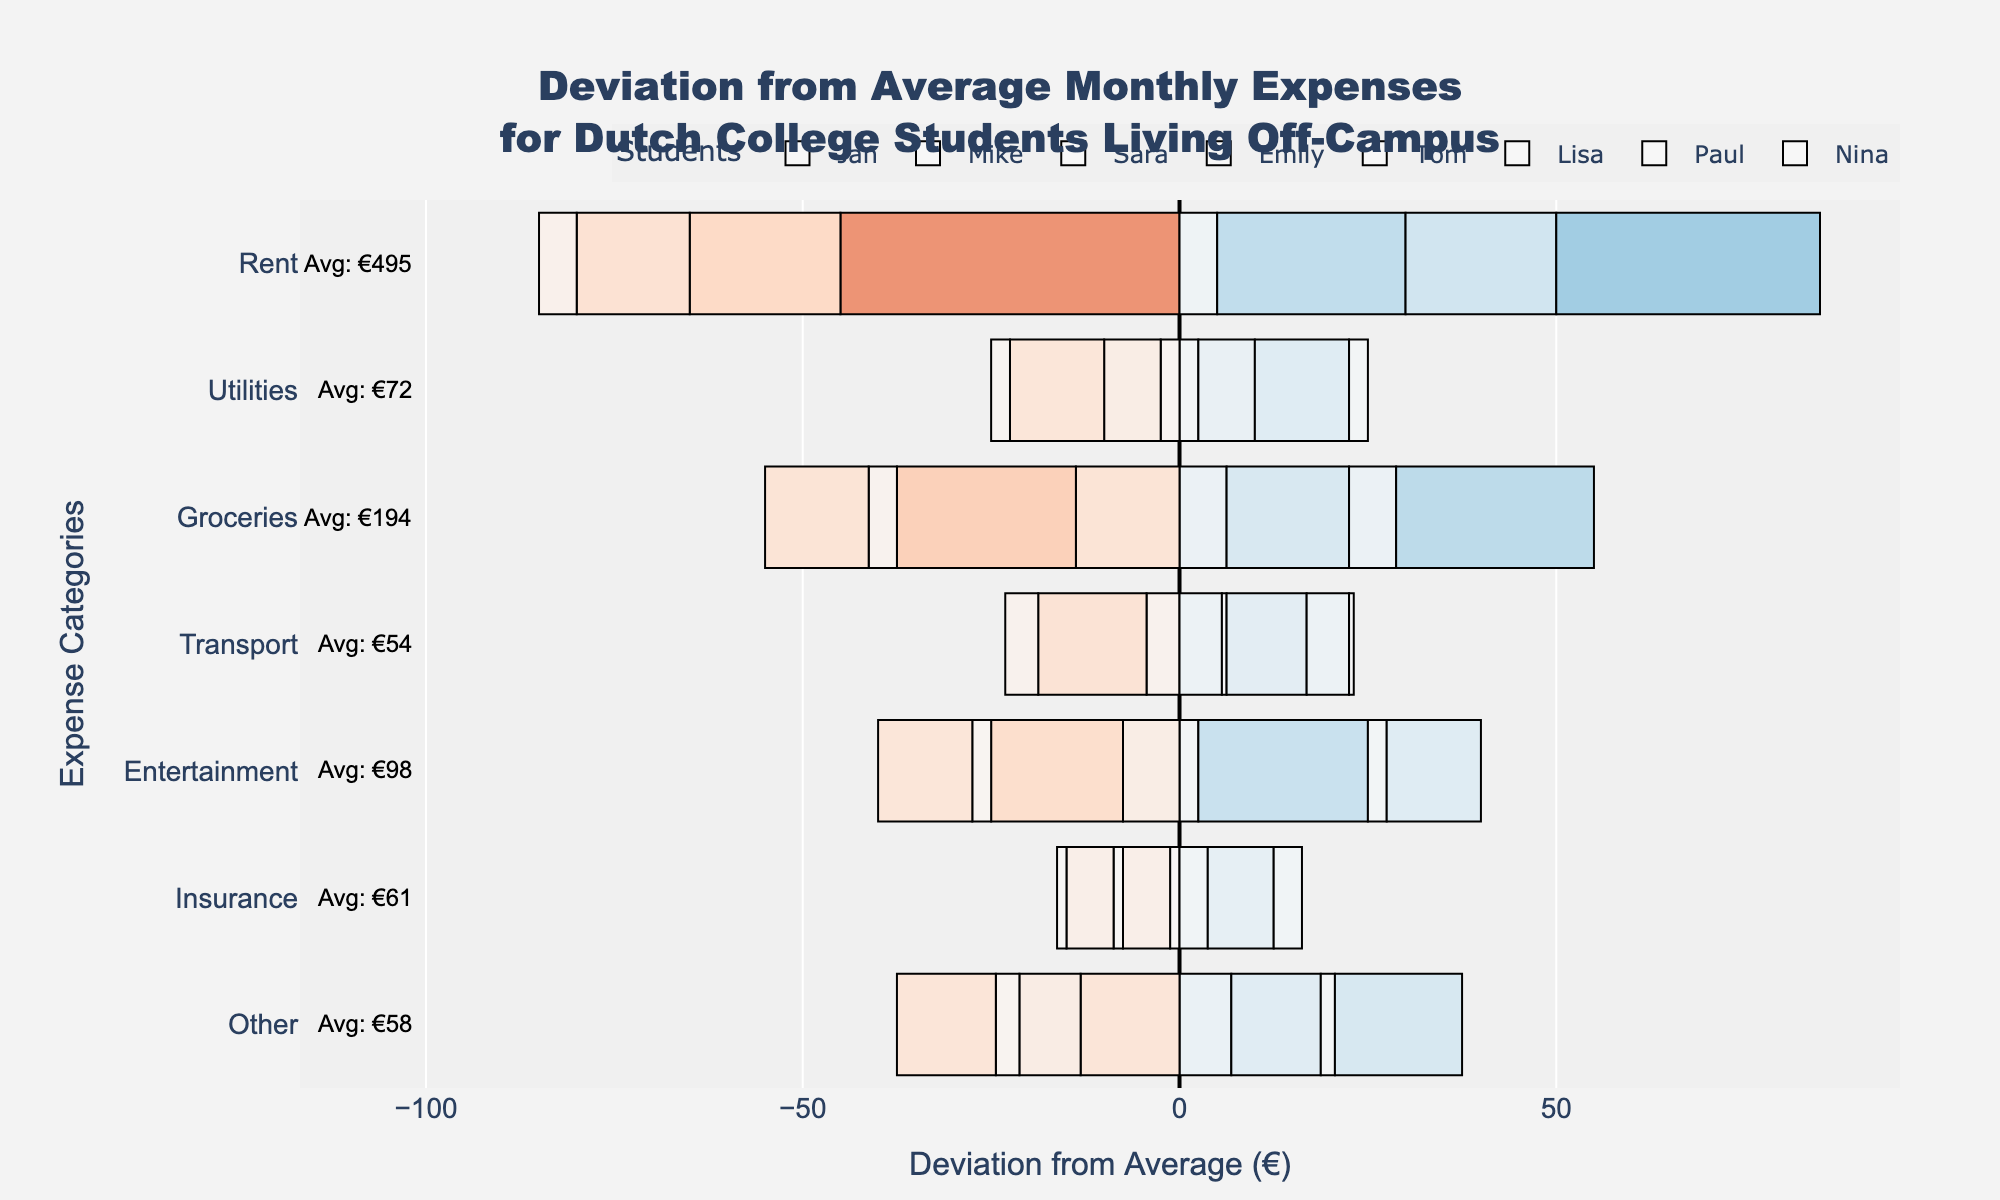What's the average rent for Dutch college students living off-campus? To find the average rent, sum the rent expenses for all students and divide by the number of students. That is (450 + 500 + 475 + 520 + 480 + 490 + 515 + 530) / 8 = 3960 / 8. The result is 495.
Answer: 495 Which student has the highest deviation for groceries expenses? By observing the chart, identify the student whose bar for groceries deviates the most from zero. The student with the highest positive deviation in groceries is Paul.
Answer: Paul What is the range of deviations for utilities expenses among the students? The deviation for utilities expenses can be observed as how spread out the bars are in this category. Lisa has the highest positive deviation and Tom has the highest negative deviation. Therefore, the range is from Lisa's positive 15 to Tom's negative -10.
Answer: 25 In which category does Nina have the largest positive deviation? Look at the bars corresponding to Nina across all categories and identify the longest bar in the positive (right) direction. It appears in the "Other" category.
Answer: Other Who spends the least on entertainment compared to the average student? Observe the bars for the entertainment category and look for the largest negative deviation. Lisa spends less on entertainment compared to the average student.
Answer: Lisa Which expense category shows the least variation among students? Identify the category where the bars are closest to zero or have minimal length differences. Utilities show the least variation among students.
Answer: Utilities Is there any student who consistently spends above the average for all categories? Look through all categories for each student and check if any student's bars are consistently on the positive side (right). No student consistently spends above the average for all categories.
Answer: No How much more or less does Emily spend on rent compared to the average? Emily's rent expenditure minus the average rent can be calculated by 520 (Emily) - 495 (average) = 25. Emily spends €25 more than the average.
Answer: €25 more Which category has the highest average expense? To find out which category has the highest average expense, check the annotation next to each category and find the largest value. Rent has the highest average expense.
Answer: Rent What is the total deviation for Paul across all expense categories? Sum the deviations (both positive and negative) for each category for Paul. It involves calculating differences: (515 - 495) + (75 - 71.25) + (220 - 191.25) + (60 - 55) + (95 - 97.5) + (60 - 61.25) + (45 - 58.125). This results in 20 + 3.75 + 28.75 + 5 - 2.5 - 1.25 - 13.125 = 40.625.
Answer: 40.625 